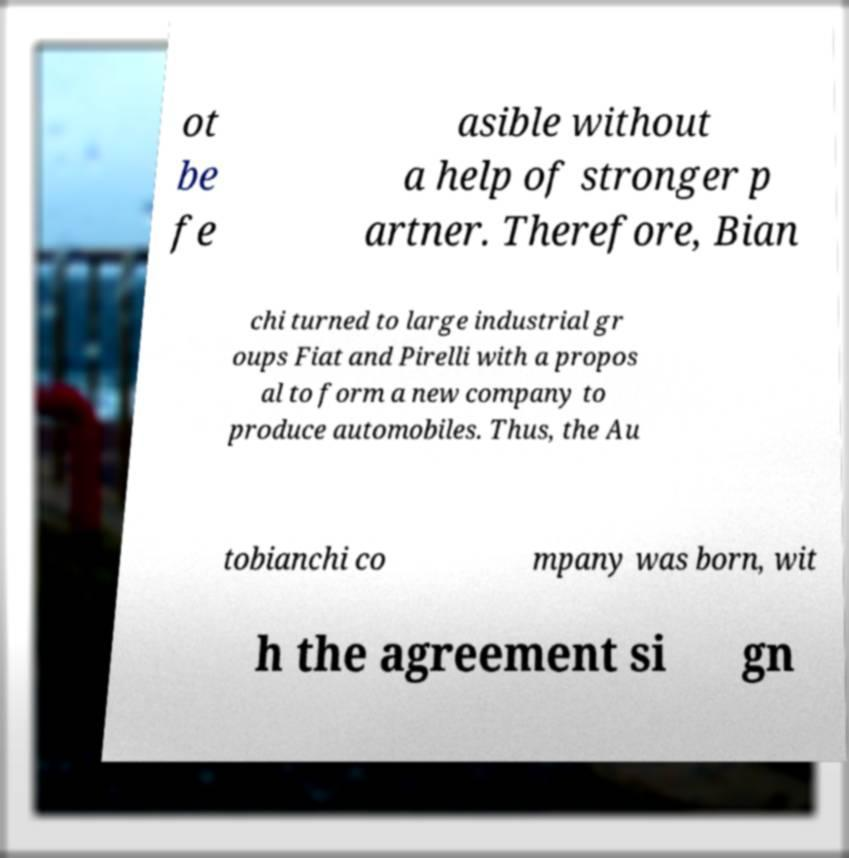Please read and relay the text visible in this image. What does it say? ot be fe asible without a help of stronger p artner. Therefore, Bian chi turned to large industrial gr oups Fiat and Pirelli with a propos al to form a new company to produce automobiles. Thus, the Au tobianchi co mpany was born, wit h the agreement si gn 